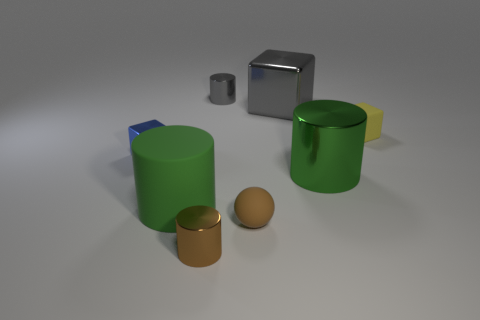Do the big metal cylinder and the matte cylinder have the same color?
Offer a terse response. Yes. Is there a shiny thing of the same color as the matte ball?
Offer a very short reply. Yes. How many objects are either small objects or small cyan matte cylinders?
Offer a terse response. 5. There is a small rubber object to the left of the large gray metallic object; is it the same color as the thing in front of the tiny rubber ball?
Your answer should be compact. Yes. What number of other objects are there of the same shape as the small yellow object?
Give a very brief answer. 2. Are there any blue spheres?
Your answer should be very brief. No. How many objects are either big blue rubber objects or small cylinders that are in front of the big gray thing?
Offer a terse response. 1. There is a metallic cylinder on the right side of the gray block; does it have the same size as the blue block?
Your answer should be very brief. No. How many other objects are the same size as the blue cube?
Your response must be concise. 4. The tiny matte sphere has what color?
Ensure brevity in your answer.  Brown. 